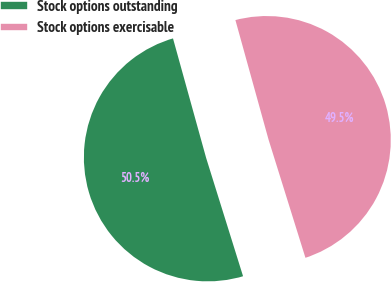Convert chart. <chart><loc_0><loc_0><loc_500><loc_500><pie_chart><fcel>Stock options outstanding<fcel>Stock options exercisable<nl><fcel>50.51%<fcel>49.49%<nl></chart> 